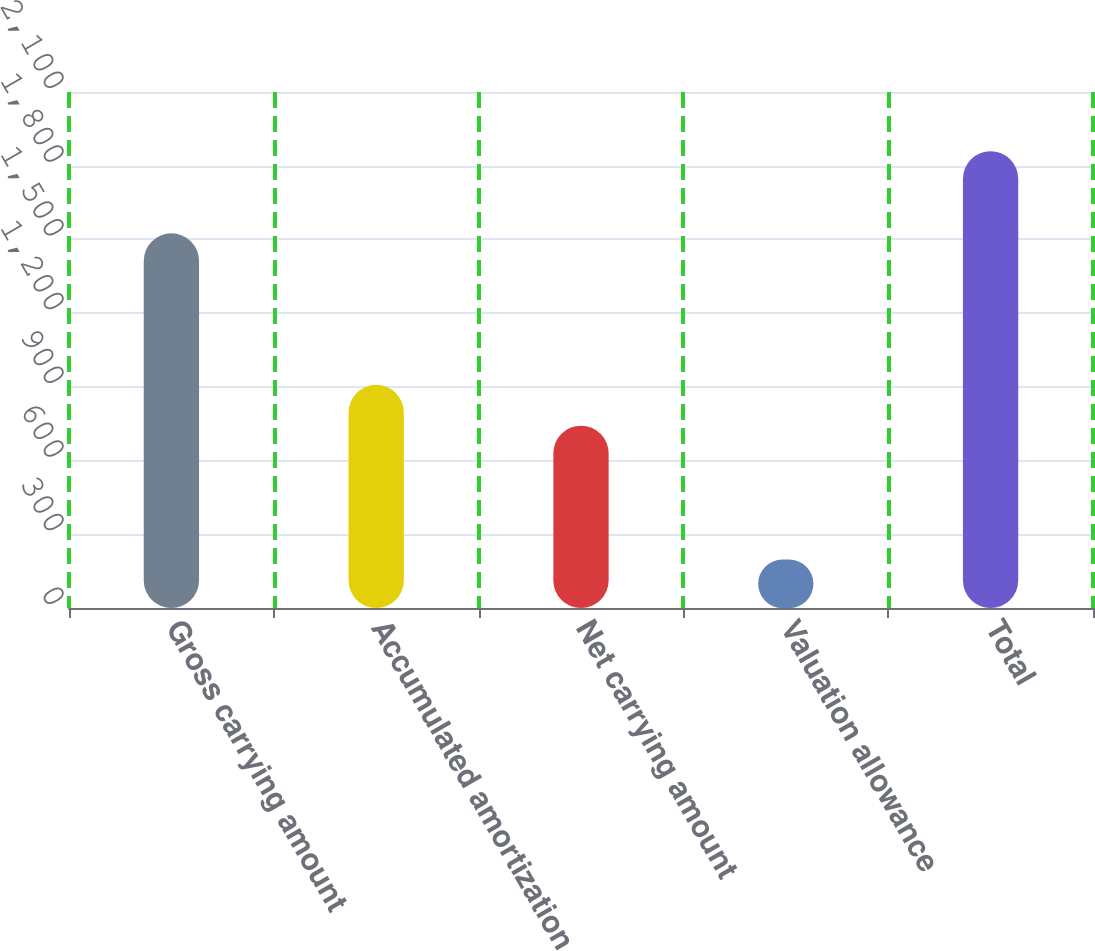<chart> <loc_0><loc_0><loc_500><loc_500><bar_chart><fcel>Gross carrying amount<fcel>Accumulated amortization<fcel>Net carrying amount<fcel>Valuation allowance<fcel>Total<nl><fcel>1525<fcel>908.2<fcel>742<fcel>197<fcel>1859<nl></chart> 